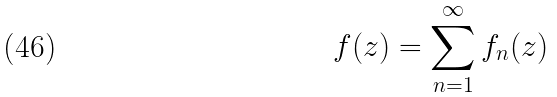Convert formula to latex. <formula><loc_0><loc_0><loc_500><loc_500>f ( z ) = \sum _ { n = 1 } ^ { \infty } { f _ { n } ( z ) }</formula> 